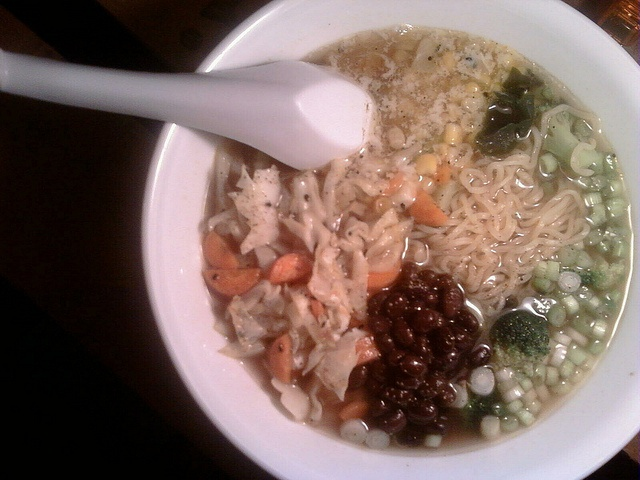Describe the objects in this image and their specific colors. I can see bowl in black, lightgray, gray, and tan tones, spoon in black, darkgray, lavender, gray, and pink tones, broccoli in black, gray, and darkgreen tones, carrot in black, brown, and maroon tones, and broccoli in black, gray, tan, and olive tones in this image. 